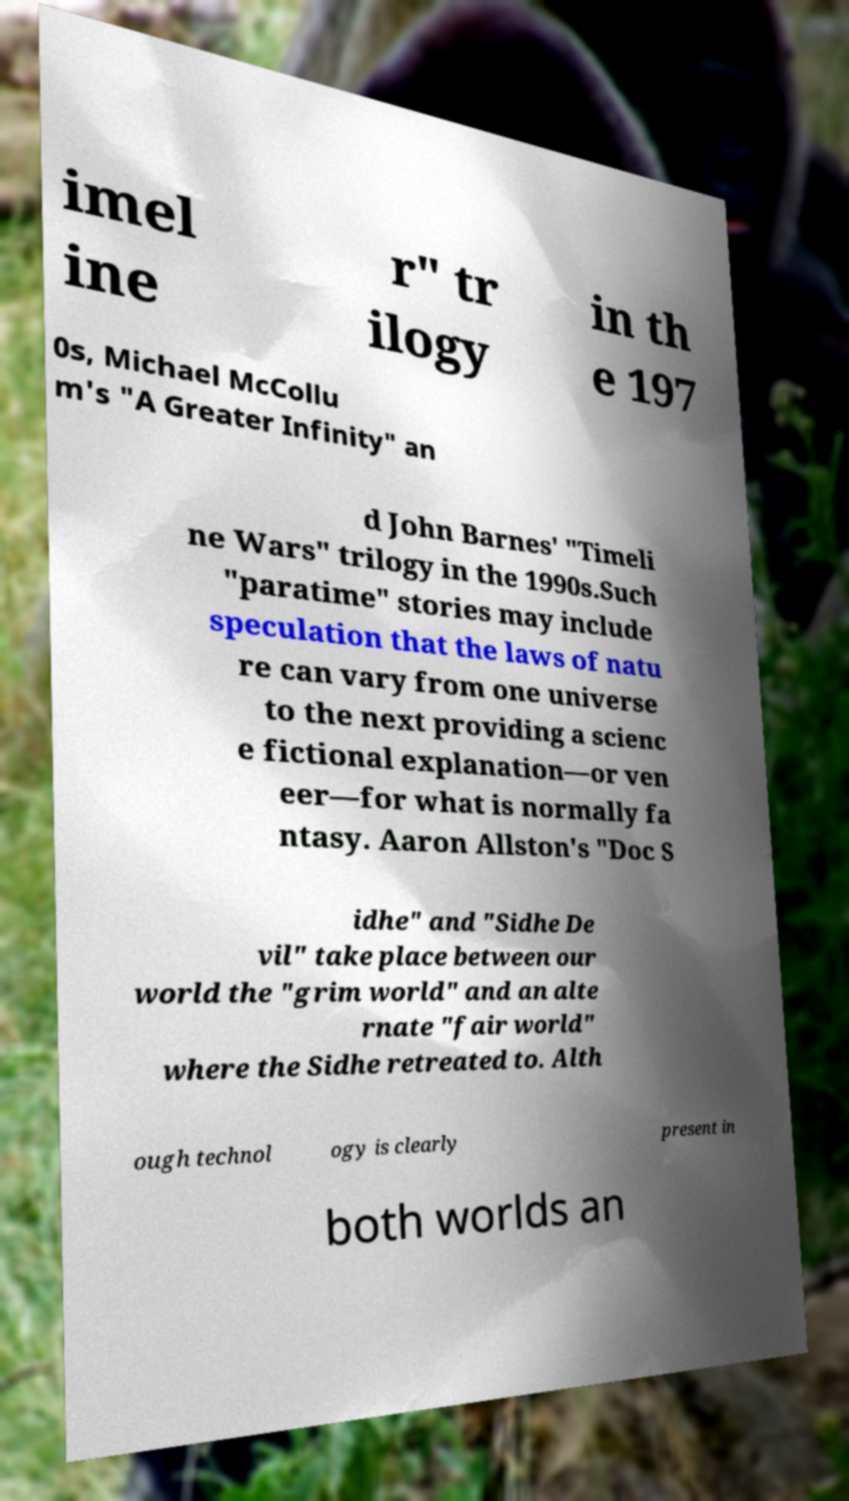For documentation purposes, I need the text within this image transcribed. Could you provide that? imel ine r" tr ilogy in th e 197 0s, Michael McCollu m's "A Greater Infinity" an d John Barnes' "Timeli ne Wars" trilogy in the 1990s.Such "paratime" stories may include speculation that the laws of natu re can vary from one universe to the next providing a scienc e fictional explanation—or ven eer—for what is normally fa ntasy. Aaron Allston's "Doc S idhe" and "Sidhe De vil" take place between our world the "grim world" and an alte rnate "fair world" where the Sidhe retreated to. Alth ough technol ogy is clearly present in both worlds an 